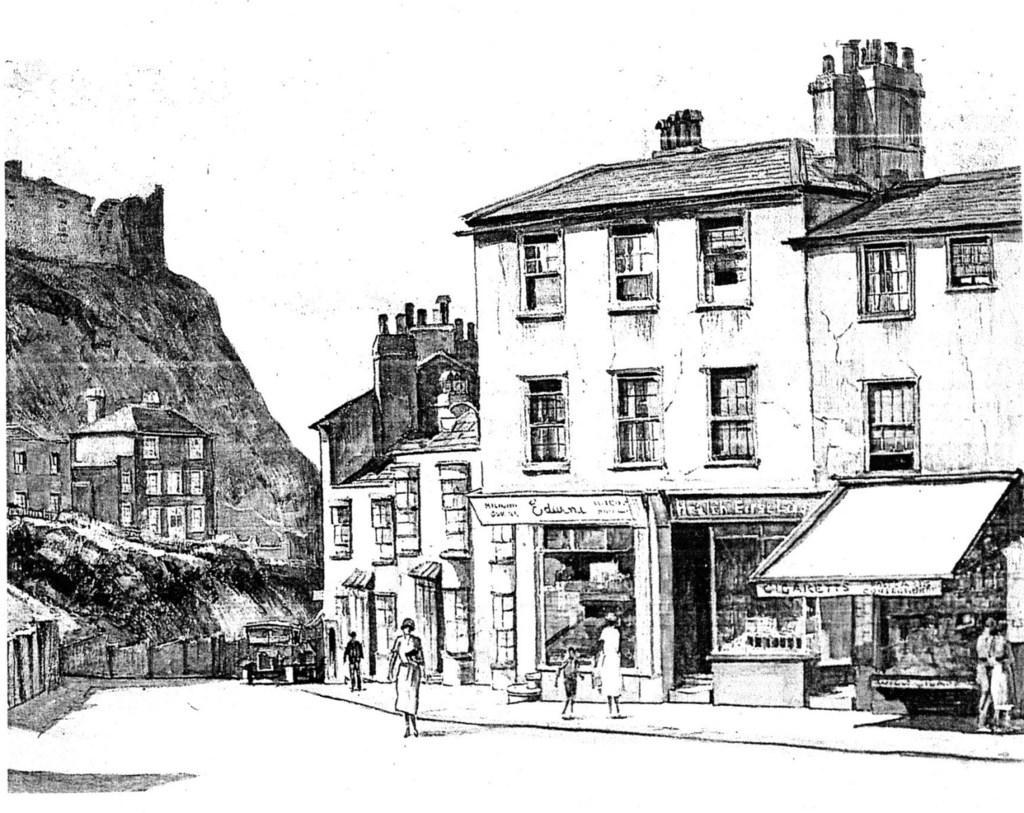Describe this image in one or two sentences. This is the painting image in which there are houses, persons and there is a vehicle and there is a fort. 